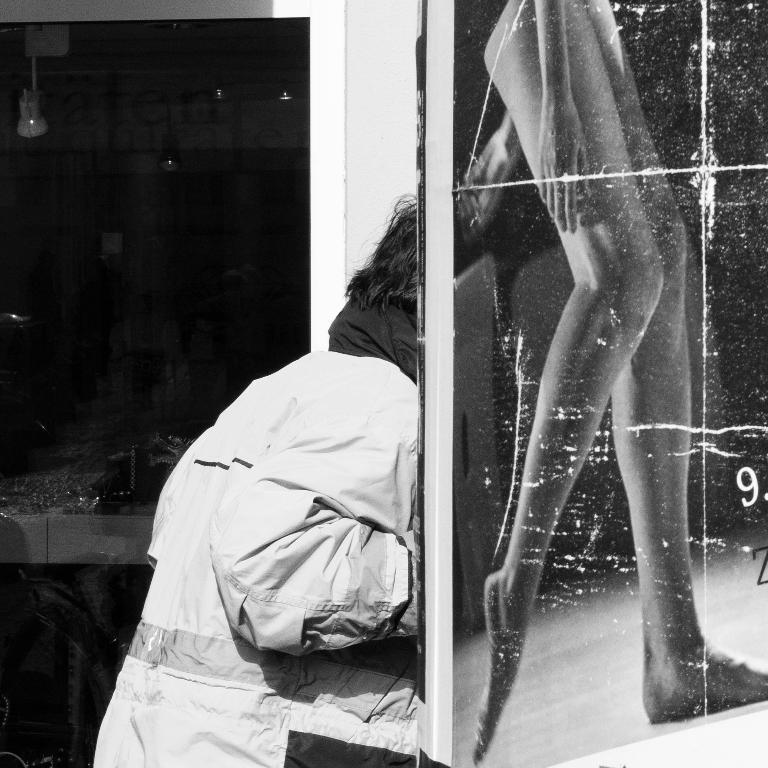Who or what is the main subject in the middle of the image? There is a person in the middle of the image. What is the person wearing in the image? The person is wearing a coat in the image. What can be seen on the right side of the image? There is an image of human legs on the right side of the image. What color scheme is used in the image? The image is in black and white color. How many bikes are visible in the image? There are no bikes present in the image. What type of board is being used by the person in the image? There is no board visible in the image; the person is wearing a coat and there is an image of human legs on the right side. 